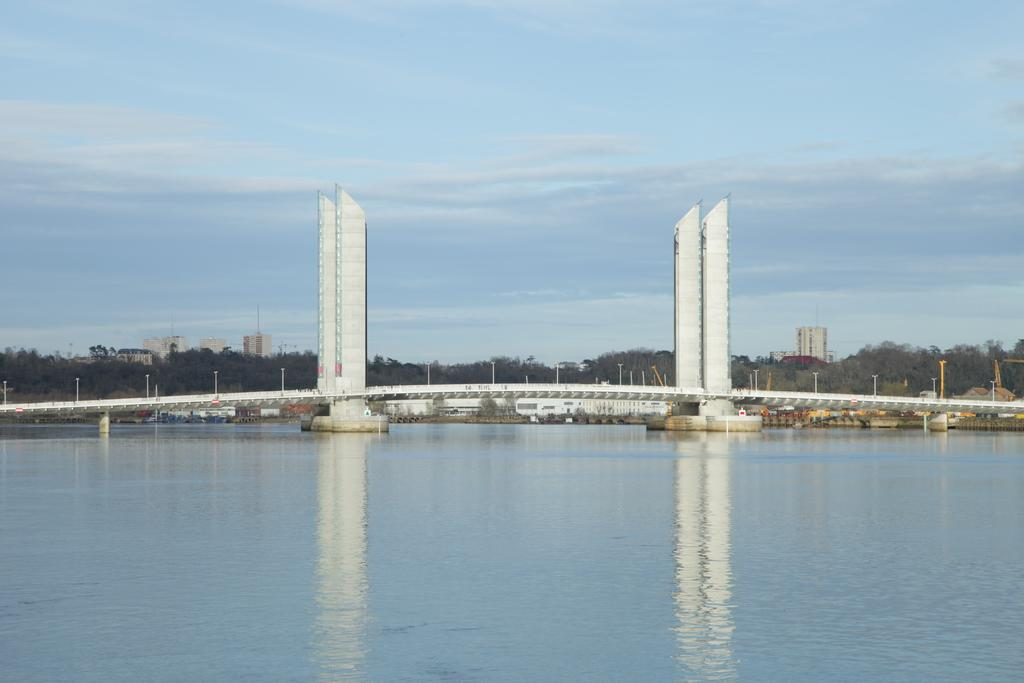What is the main subject in the center of the image? There is water in the center of the image. What can be seen in the background of the image? The sky, clouds, trees, buildings, poles, pillars, supportive rods, and a bridge are visible in the background of the image. What type of sponge can be seen growing on the bridge in the image? There is no sponge present in the image, and no plants are growing on the bridge. 